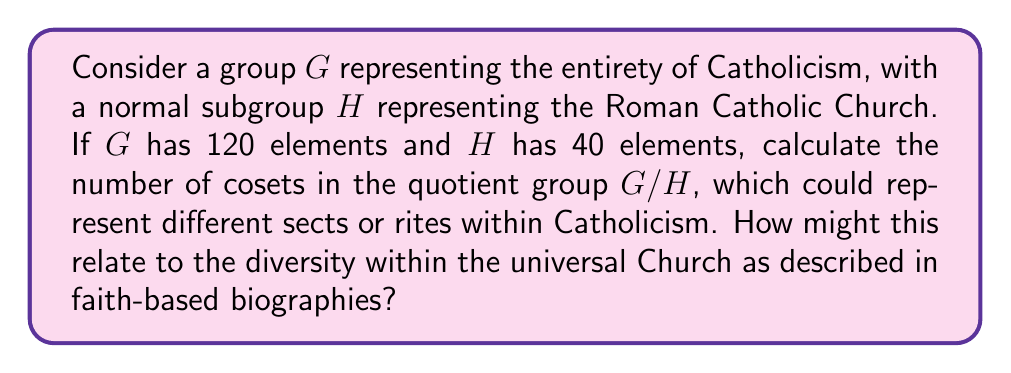What is the answer to this math problem? To solve this problem, we'll follow these steps:

1) Recall the Lagrange's Theorem, which states that for a finite group $G$ and a subgroup $H$ of $G$, the order of $H$ divides the order of $G$. The quotient of these orders gives the index of $H$ in $G$, which is equal to the number of cosets of $H$ in $G$.

2) We are given:
   $|G| = 120$ (order of the entire group)
   $|H| = 40$ (order of the normal subgroup)

3) The number of cosets in $G/H$ is equal to the index of $H$ in $G$, which we can calculate as:

   $$[G:H] = \frac{|G|}{|H|} = \frac{120}{40} = 3$$

4) This result tells us that there are 3 cosets in the quotient group $G/H$.

5) In the context of Catholicism, this could be interpreted as representing three main divisions or rites within the Church. For example, this might correspond to the Latin (Roman) Rite, Eastern Catholic Churches, and Anglican Use.

6) The fact that these are cosets of a normal subgroup could be seen as reflecting that these divisions, while distinct, are all part of the universal Catholic Church and share core beliefs and practices.

7) This mathematical representation aligns with the Catholic understanding of unity in diversity, a theme often explored in faith-based biographies of saints and Church leaders from various traditions within Catholicism.
Answer: The number of cosets in the quotient group $G/H$ is 3. 